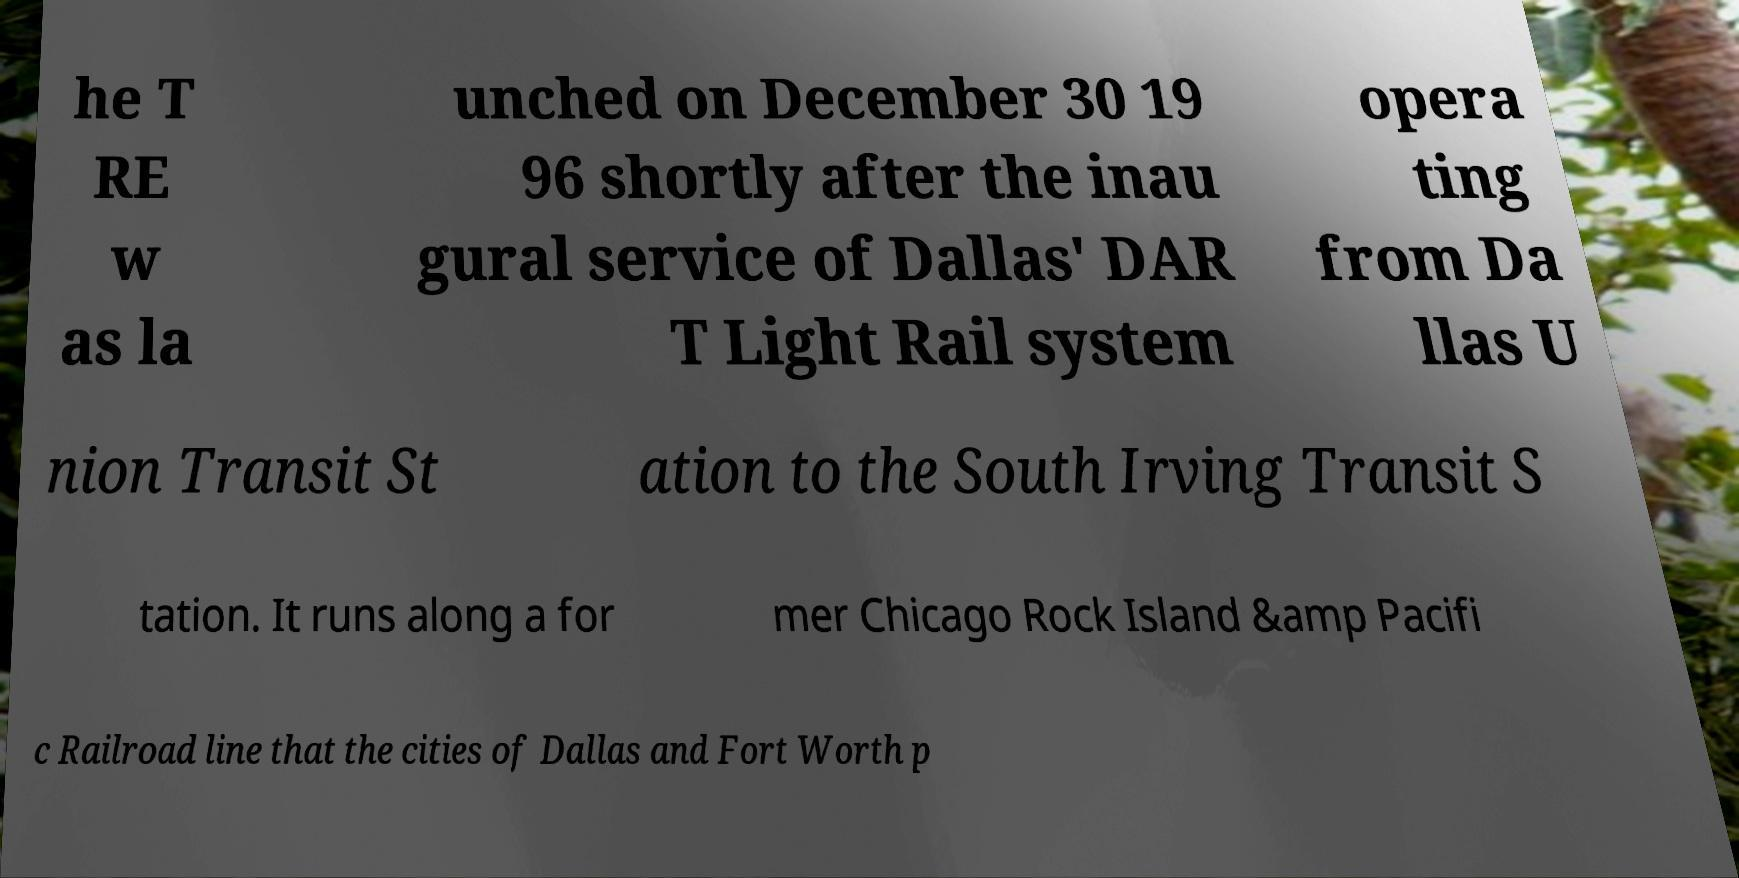Please read and relay the text visible in this image. What does it say? he T RE w as la unched on December 30 19 96 shortly after the inau gural service of Dallas' DAR T Light Rail system opera ting from Da llas U nion Transit St ation to the South Irving Transit S tation. It runs along a for mer Chicago Rock Island &amp Pacifi c Railroad line that the cities of Dallas and Fort Worth p 